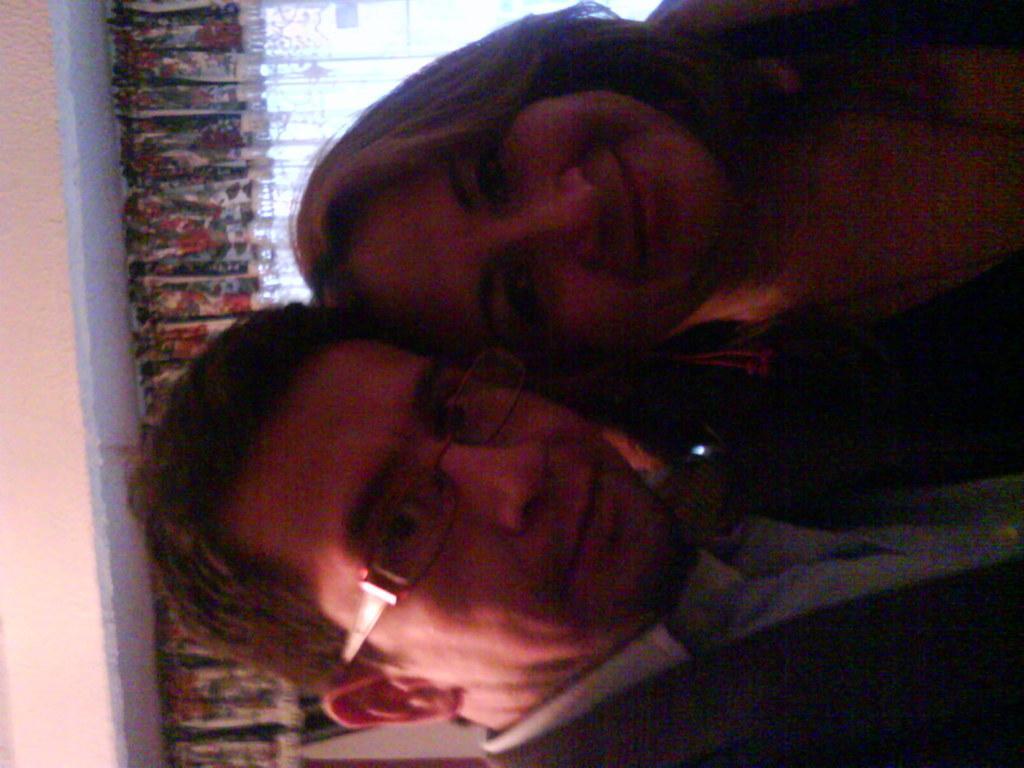In one or two sentences, can you explain what this image depicts? In the foreground of this image, there is a man and a woman posing to a camera. In the background, there is a curtain and the wall. 